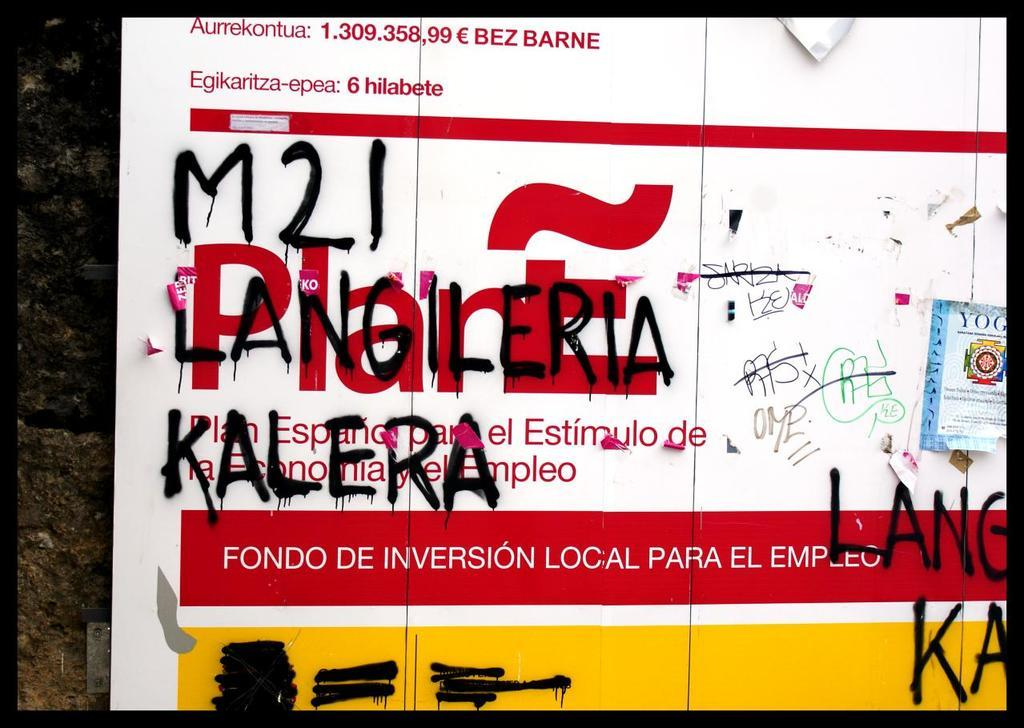<image>
Render a clear and concise summary of the photo. An advertisement defaced by the use of M21 Langileria Kalera written in black letters. 